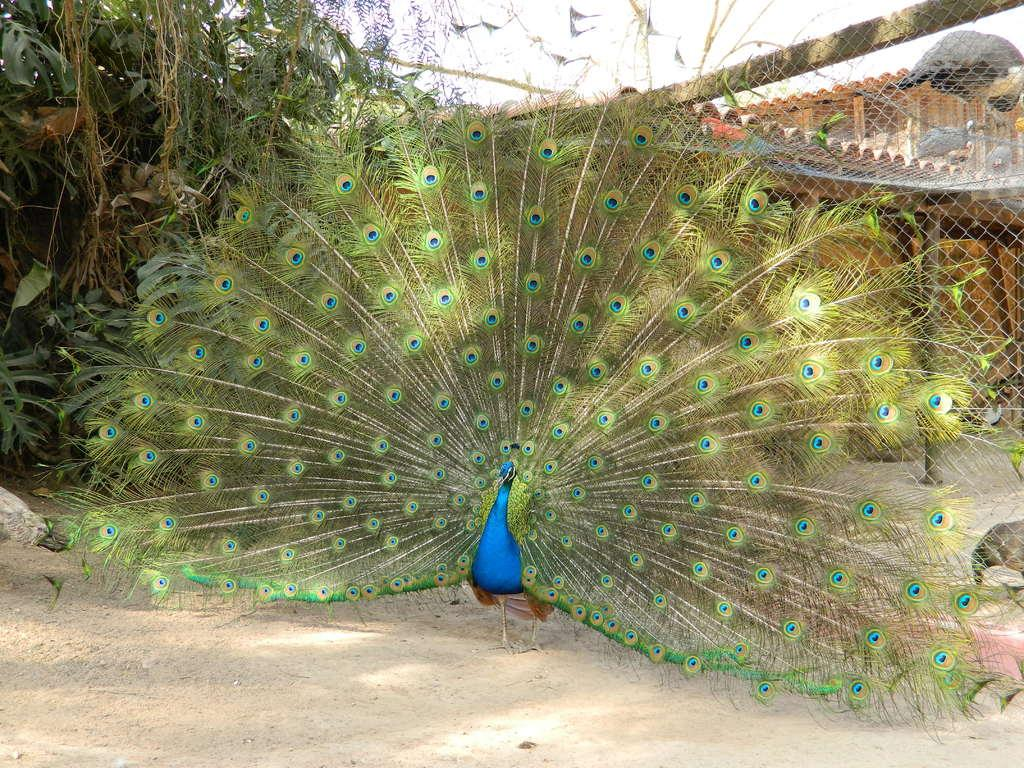What type of animal is in the image? There is a peacock in the image. What colors can be seen on the peacock? The peacock has blue, green, and brown colors. Where is the peacock located in the image? The peacock is standing on the ground. What can be seen in the background of the image? There are trees and other birds visible in the background, as well as the sky. What type of hat is the peacock wearing in the image? The peacock is not wearing a hat in the image; it is a bird with feathers. 